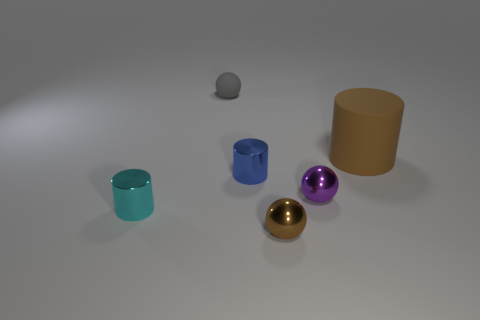Subtract all shiny spheres. How many spheres are left? 1 Add 3 big brown metallic objects. How many objects exist? 9 Subtract all cyan cylinders. How many cylinders are left? 2 Add 1 purple things. How many purple things are left? 2 Add 1 small purple rubber objects. How many small purple rubber objects exist? 1 Subtract 0 brown blocks. How many objects are left? 6 Subtract all blue cylinders. Subtract all purple spheres. How many cylinders are left? 2 Subtract all small cylinders. Subtract all shiny spheres. How many objects are left? 2 